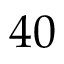Convert formula to latex. <formula><loc_0><loc_0><loc_500><loc_500>4 0</formula> 